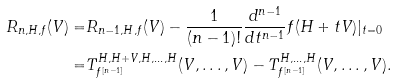Convert formula to latex. <formula><loc_0><loc_0><loc_500><loc_500>R _ { n , H , f } ( V ) = & R _ { n - 1 , H , f } ( V ) - \frac { 1 } { ( n - 1 ) ! } \frac { d ^ { n - 1 } } { d t ^ { n - 1 } } f ( H + t V ) | _ { t = 0 } \\ = & T ^ { H , H + V , H , \dots , H } _ { f ^ { [ n - 1 ] } } ( V , \dots , V ) - T ^ { H , \dots , H } _ { f ^ { [ n - 1 ] } } ( V , \dots , V ) .</formula> 